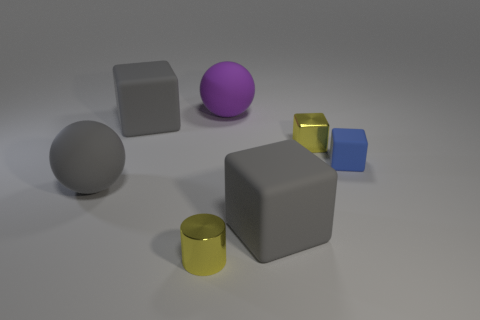How big is the matte sphere on the right side of the gray cube behind the tiny yellow metal block?
Keep it short and to the point. Large. Is the number of yellow objects behind the metallic cylinder the same as the number of small matte objects to the left of the gray matte ball?
Make the answer very short. No. There is a small yellow object behind the small blue block; are there any large gray blocks behind it?
Your answer should be compact. Yes. There is a blue thing that is made of the same material as the gray sphere; what shape is it?
Your response must be concise. Cube. Is there anything else of the same color as the metallic block?
Ensure brevity in your answer.  Yes. There is a yellow object that is on the left side of the yellow shiny object to the right of the purple sphere; what is its material?
Keep it short and to the point. Metal. Is there a small yellow shiny object of the same shape as the purple thing?
Make the answer very short. No. What number of other objects are the same shape as the blue thing?
Your response must be concise. 3. There is a thing that is both behind the small blue matte thing and left of the cylinder; what is its shape?
Your response must be concise. Cube. What size is the gray block in front of the small blue block?
Your response must be concise. Large. 